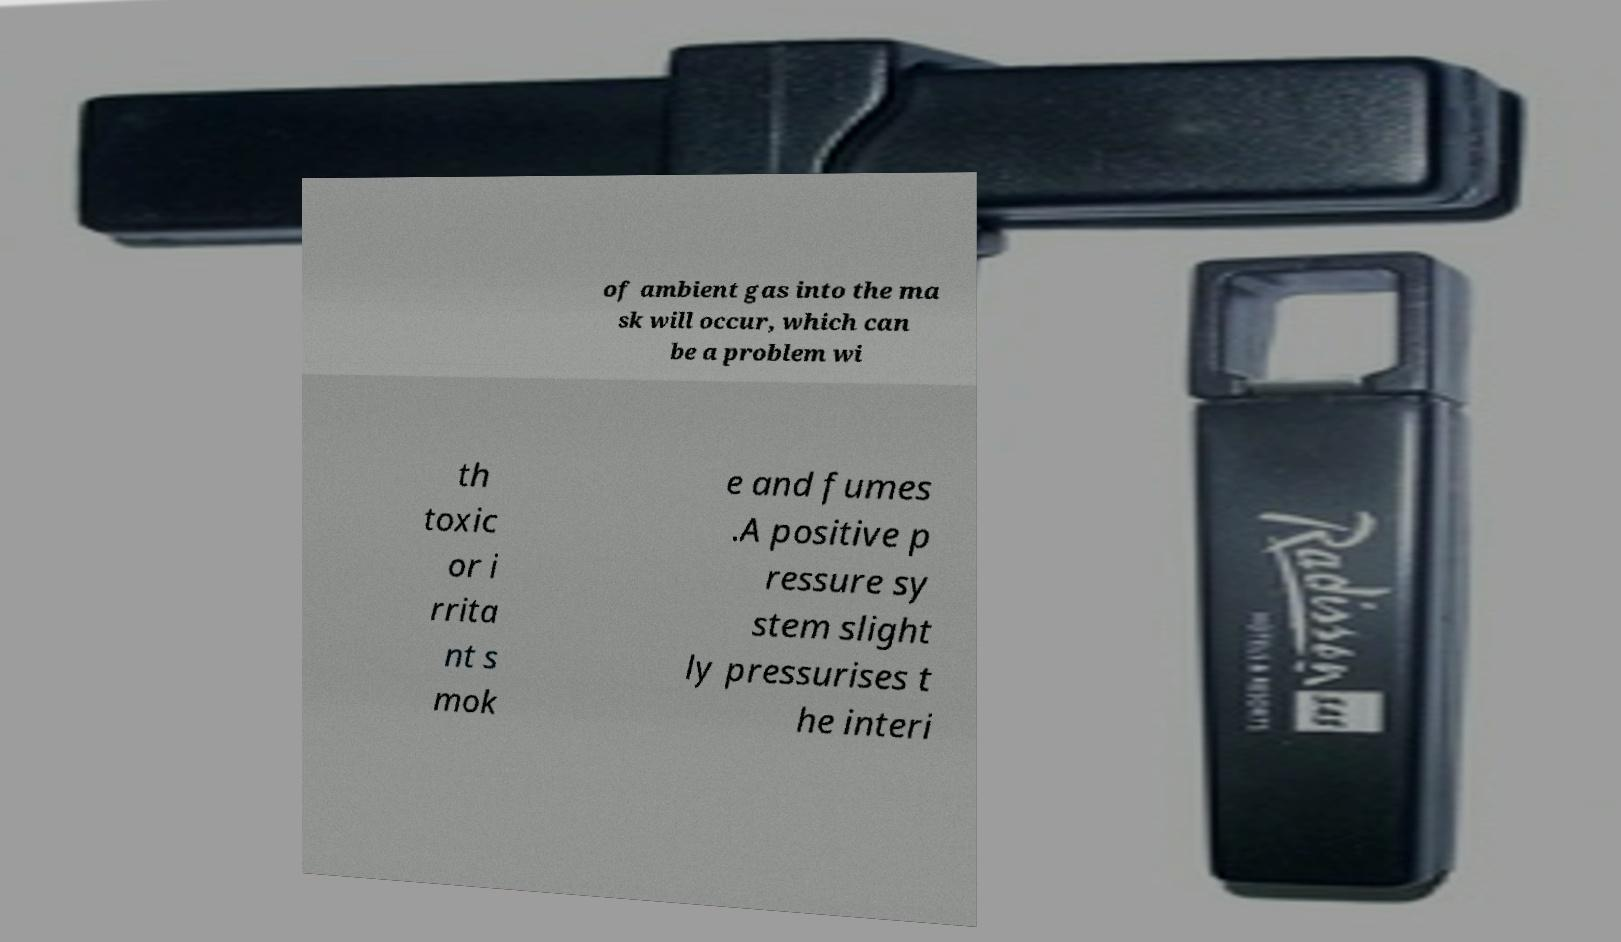Please identify and transcribe the text found in this image. of ambient gas into the ma sk will occur, which can be a problem wi th toxic or i rrita nt s mok e and fumes .A positive p ressure sy stem slight ly pressurises t he interi 